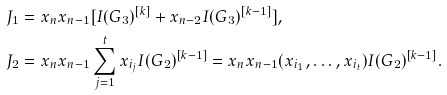<formula> <loc_0><loc_0><loc_500><loc_500>J _ { 1 } & = x _ { n } x _ { n - 1 } [ I ( G _ { 3 } ) ^ { [ k ] } + x _ { n - 2 } I ( G _ { 3 } ) ^ { [ k - 1 ] } ] , \\ J _ { 2 } & = x _ { n } x _ { n - 1 } \sum _ { j = 1 } ^ { t } x _ { i _ { j } } I ( G _ { 2 } ) ^ { [ k - 1 ] } = x _ { n } x _ { n - 1 } ( x _ { i _ { 1 } } , \dots , x _ { i _ { t } } ) I ( G _ { 2 } ) ^ { [ k - 1 ] } .</formula> 